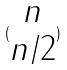Convert formula to latex. <formula><loc_0><loc_0><loc_500><loc_500>( \begin{matrix} n \\ n / 2 \end{matrix} )</formula> 